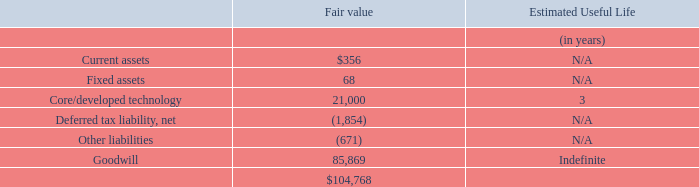Proofpoint, Inc. Notes to Consolidated Financial Statements (Continued) (dollars and share amounts in thousands, except per share amounts)
Per the terms of the share purchase agreement, unvested stock options and unvested restricted stock units held by Meta Networks employees were canceled and exchanged for the Company’s unvested stock options and unvested restricted stock units, respectively. The fair value of $184 of these unvested awards was attributed to pre-combination services and was included in consideration transferred. The fair value of $12,918 was allocated to post-combination services. The unvested awards are subject to the recipient’s continued service with the Company, and $12,918 will be recognized ratably as stock-based compensation expense over the required remaining service period.
Also, as part of the share purchase agreement, the unvested restricted shares of certain employees of Meta Networks were exchanged into the right to receive $7,827 of deferred cash consideration and 72 shares of the Company’s common stock that were deferred with the fair value of $8,599. The deferred cash consideration was presented as restricted cash on the Company’s consolidated balance sheet as of December 31, 2019. The deferred cash consideration of $7,596 and the deferred stock $8,338 (see Note 11 “Equity Award Plans”) were allocated to post-combination expense and were not included in the purchase price. The deferred cash consideration and deferred shares are subject to forfeiture if employment terminates prior to the lapse of the restrictions, and their fair value is expensed as compensation and stock-based compensation expense over the three-year vesting period.
The Cost to Recreate Method was used to value the acquired developed technology asset. Management applied judgment in estimating the fair value of this intangible asset, which involved the use of significant assumptions such as the cost and time to build the acquired technology, developer’s profit and rate of return.
The following table summarizes the fair values of tangible assets acquired, liabilities assumed, intangible assets and goodwill:
What method was used to value the acquired developed technology asset?  Cost to recreate method. Which subject has the highest estimated useful life? Goodwill. What was the deferred cash consideration and deferred shares subjected to? Forfeiture if employment terminates prior to the lapse of the restrictions, and their fair value is expensed as compensation and stock-based compensation expense over the three-year vesting period. What is the difference in estimated fair value between current assets and fixed assets?
Answer scale should be: thousand. $356 - 68
Answer: 288. What is the average estimated fair value of Core/developed technology?
Answer scale should be: thousand. 21,000 / 3
Answer: 7000. What is the total estimated fair value of all assets?
Answer scale should be: thousand. $356 + 68 + 21,000
Answer: 21424. 